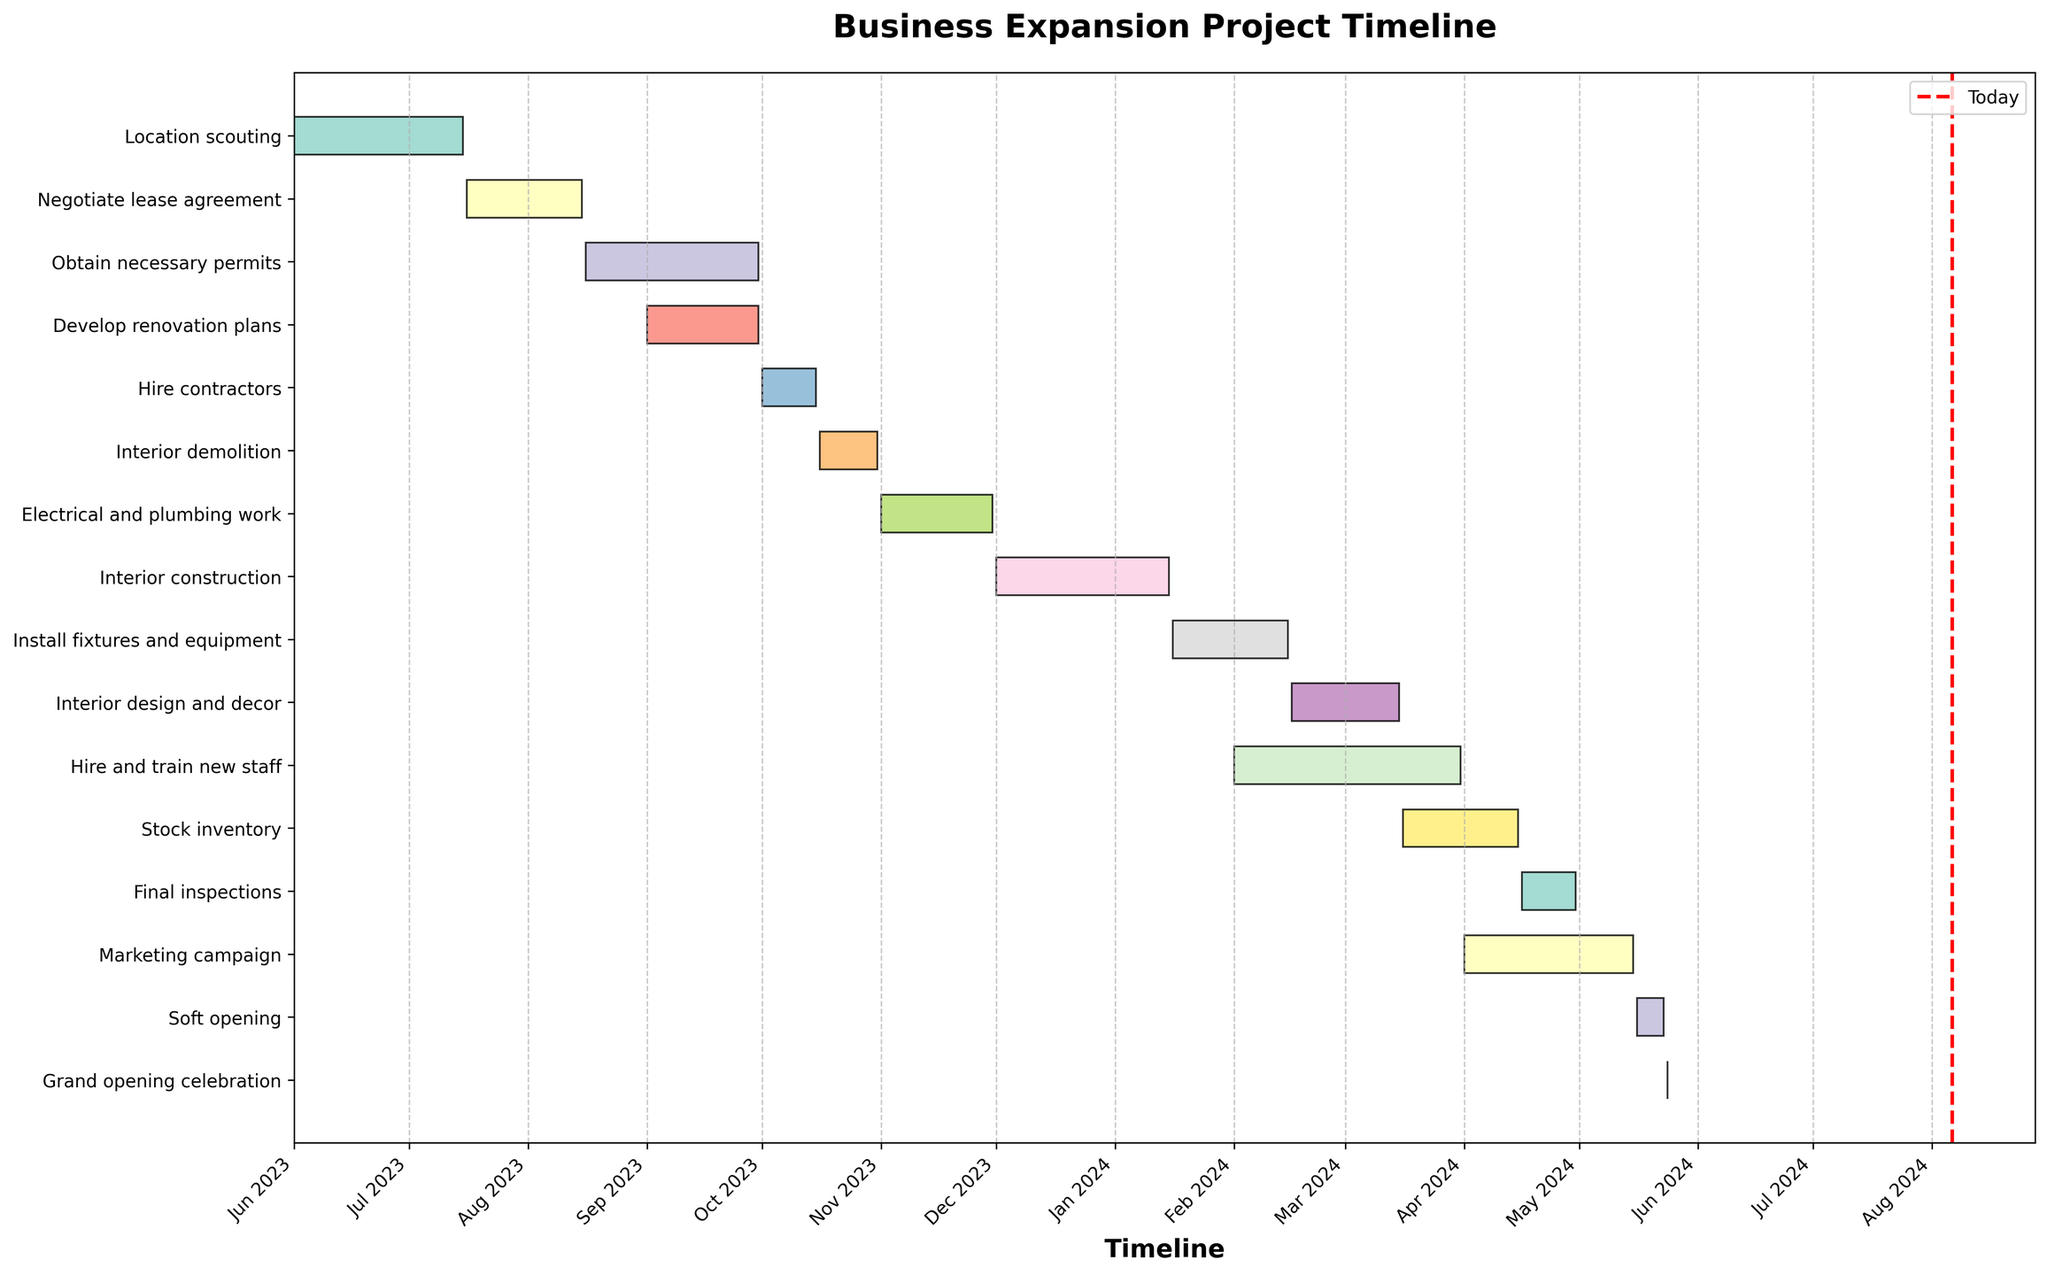What is the title of the Gantt chart? The title is usually the largest text, located at the top of the plot. In this case, it reads "Business Expansion Project Timeline."
Answer: Business Expansion Project Timeline Which task represents the shortest duration, and how long does it last? Locate the bar with the smallest length in the chart. The "Grand opening celebration" bar appears shortest, and since it spans only one day (May 24, 2024), the duration is one day.
Answer: Grand opening celebration, 1 day What are the start and end dates for the "Interior demolition" phase? Find the "Interior demolition" row on the y-axis. The task starts on October 16, 2023, and ends on October 31, 2023.
Answer: October 16, 2023 - October 31, 2023 Which phases overlap with the "Electrical and plumbing work" phase? Observe tasks that have bars overlapping with "Electrical and plumbing work" within the timeline. "Electrical and plumbing work" takes place between November 1, 2023, and November 30, 2023. "Interior construction" (which starts December 1, 2023), has no overlap. So, no other phases overlap with it.
Answer: None How many phases are scheduled to be completed within the year 2024? Count the tasks that end in 2024. These are "Interior construction," "Install fixtures and equipment," "Interior design and decor," "Hire and train new staff," "Stock inventory," "Final inspections," "Marketing campaign," "Soft opening," and "Grand opening celebration." Hence, there are 9 tasks.
Answer: 9 During which months does the "Marketing campaign" phase take place? The "Marketing campaign" phase starts on April 1, 2024, and ends on May 15, 2024. Thus, it takes place in April and May.
Answer: April and May In terms of completion time, which one takes longer – "Develop renovation plans" or "Obtain necessary permits"? Check the duration for both tasks. "Develop renovation plans" lasts from September 1, 2023, to September 30, 2023 (30 days), and "Obtain necessary permits" lasts from August 16, 2023, to September 30, 2023 (46 days). "Obtain necessary permits" takes longer.
Answer: Obtain necessary permits What is the total duration (in days) for the "Hire contractors" and "Interior demolition" phases combined? "Hire contractors" spans from October 1, 2023, to October 15, 2023 (15 days), and "Interior demolition" from October 16, 2023, to October 31, 2023 (16 days). Add the durations: 15 + 16 = 31 days.
Answer: 31 days Which phase follows immediately after "Stock inventory"? Look for the next task beginning after "Stock inventory," which ends on April 15, 2024. "Final inspections" starts on April 16, 2024.
Answer: Final inspections 